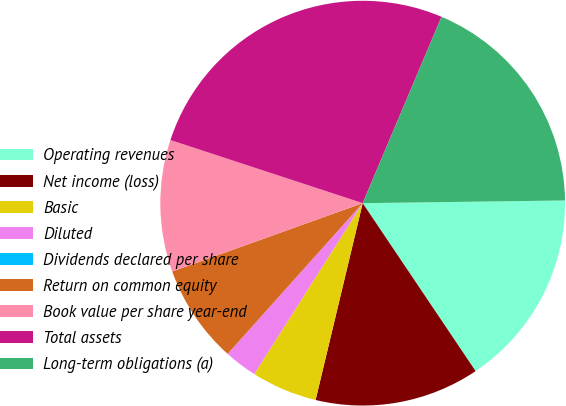Convert chart to OTSL. <chart><loc_0><loc_0><loc_500><loc_500><pie_chart><fcel>Operating revenues<fcel>Net income (loss)<fcel>Basic<fcel>Diluted<fcel>Dividends declared per share<fcel>Return on common equity<fcel>Book value per share year-end<fcel>Total assets<fcel>Long-term obligations (a)<nl><fcel>15.79%<fcel>13.16%<fcel>5.26%<fcel>2.63%<fcel>0.0%<fcel>7.89%<fcel>10.53%<fcel>26.32%<fcel>18.42%<nl></chart> 